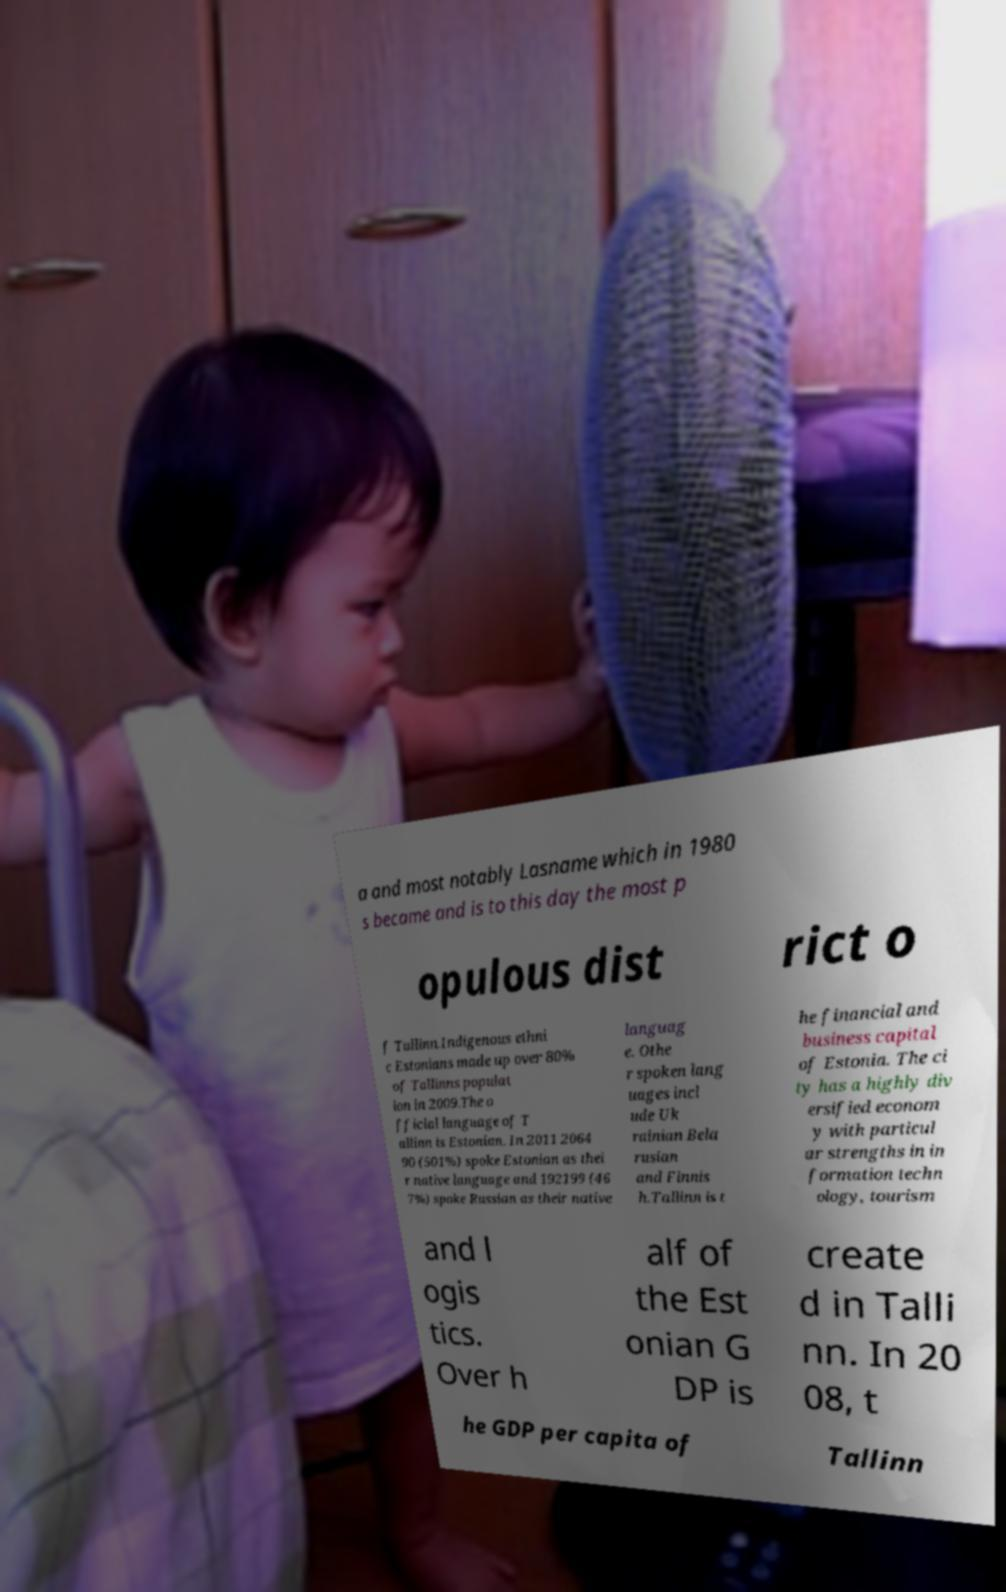Could you assist in decoding the text presented in this image and type it out clearly? a and most notably Lasname which in 1980 s became and is to this day the most p opulous dist rict o f Tallinn.Indigenous ethni c Estonians made up over 80% of Tallinns populat ion in 2009.The o fficial language of T allinn is Estonian. In 2011 2064 90 (501%) spoke Estonian as thei r native language and 192199 (46 7%) spoke Russian as their native languag e. Othe r spoken lang uages incl ude Uk rainian Bela rusian and Finnis h.Tallinn is t he financial and business capital of Estonia. The ci ty has a highly div ersified econom y with particul ar strengths in in formation techn ology, tourism and l ogis tics. Over h alf of the Est onian G DP is create d in Talli nn. In 20 08, t he GDP per capita of Tallinn 